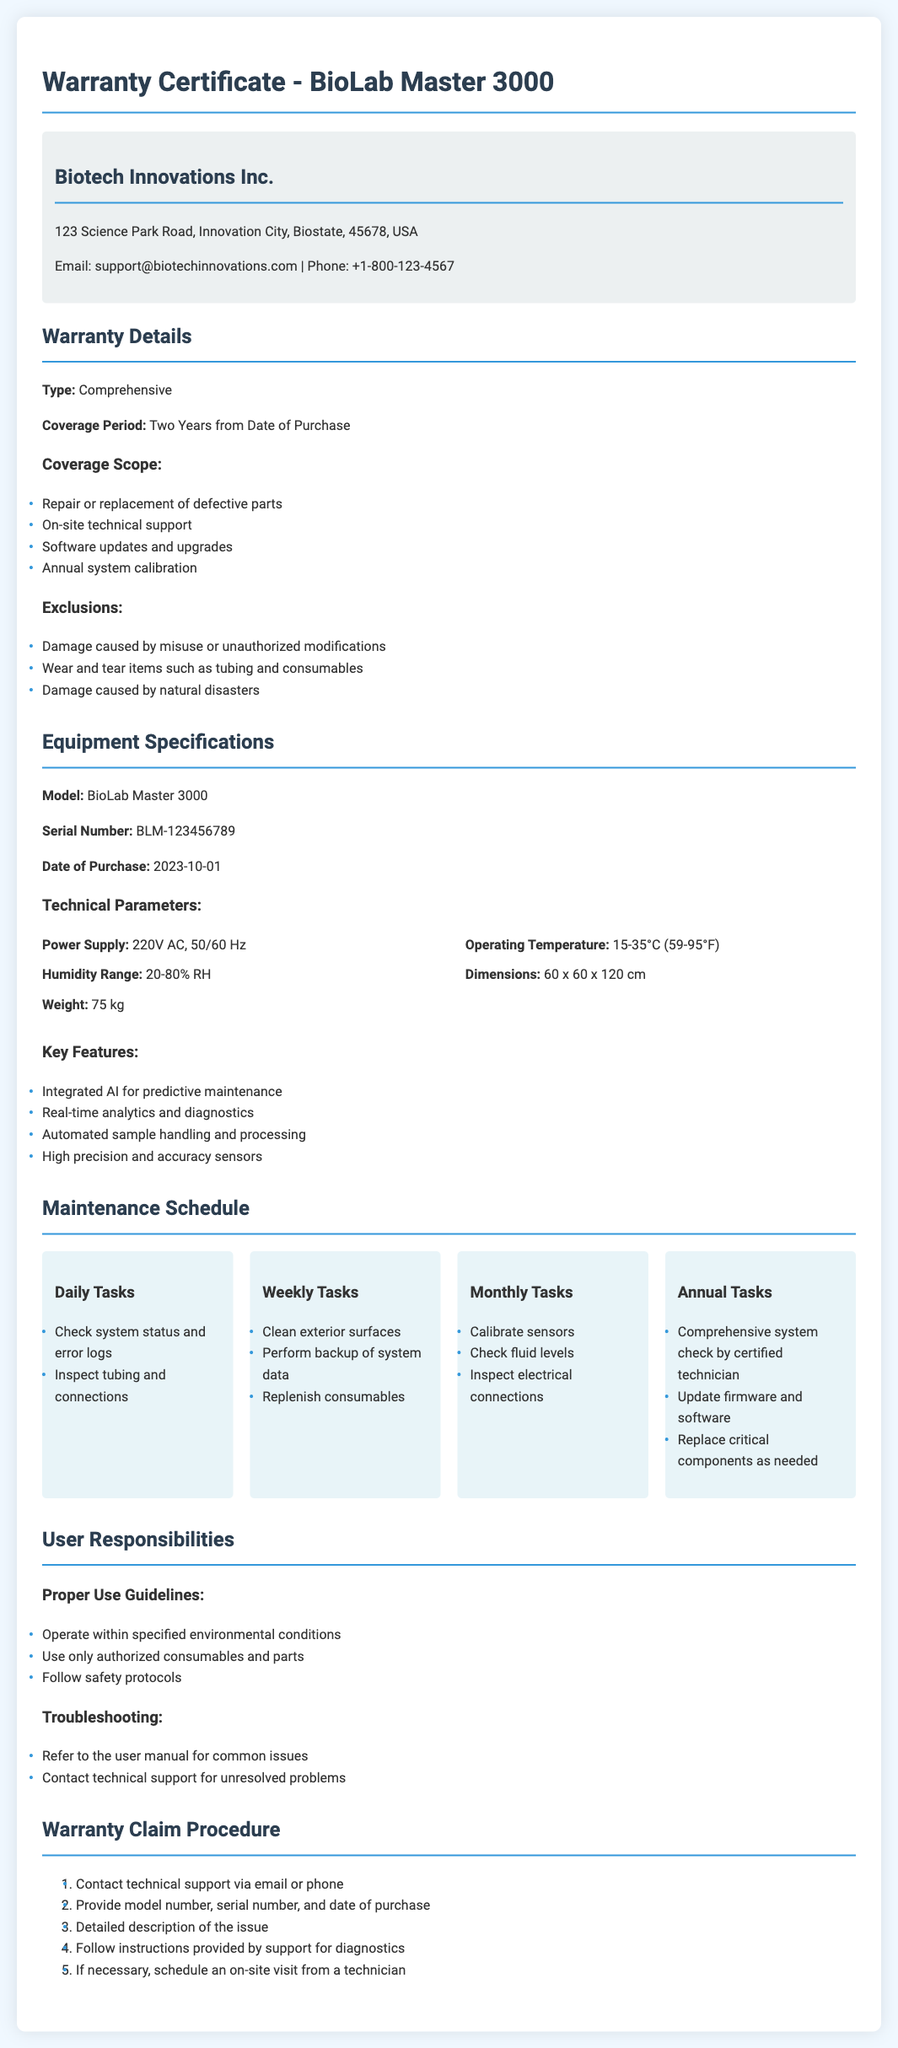what is the type of warranty? The type of warranty is specified in the document as "Comprehensive."
Answer: Comprehensive what is the coverage period of the warranty? The coverage period is the duration from the date of purchase specified in the document. It states “Two Years from Date of Purchase.”
Answer: Two Years which company provides the warranty? The document includes the name of the company that provides the warranty. It states "Biotech Innovations Inc."
Answer: Biotech Innovations Inc what is the serial number of the equipment? The document gives the serial number of the equipment in the specifications section as "BLM-123456789."
Answer: BLM-123456789 what is one exclusion listed in the warranty? The document lists items that are specifically excluded from coverage within the warranty details. One example is "Damage caused by misuse or unauthorized modifications."
Answer: Damage caused by misuse or unauthorized modifications what frequency is the system calibration performed? The document mentions the frequency at which system calibration is included in the warranty coverage details. It states "Annual system calibration."
Answer: Annual what is the power supply specification? The technical parameters section of the document provides information about the power supply. It specifies "220V AC, 50/60 Hz."
Answer: 220V AC, 50/60 Hz what task is included in the annual maintenance schedule? The maintenance schedule describes tasks to perform annually. One such task is "Comprehensive system check by certified technician."
Answer: Comprehensive system check by certified technician how many daily tasks are listed in the maintenance schedule? The document specifies daily tasks in the maintenance schedule, indicating the number provided. There are “2” daily tasks.
Answer: 2 